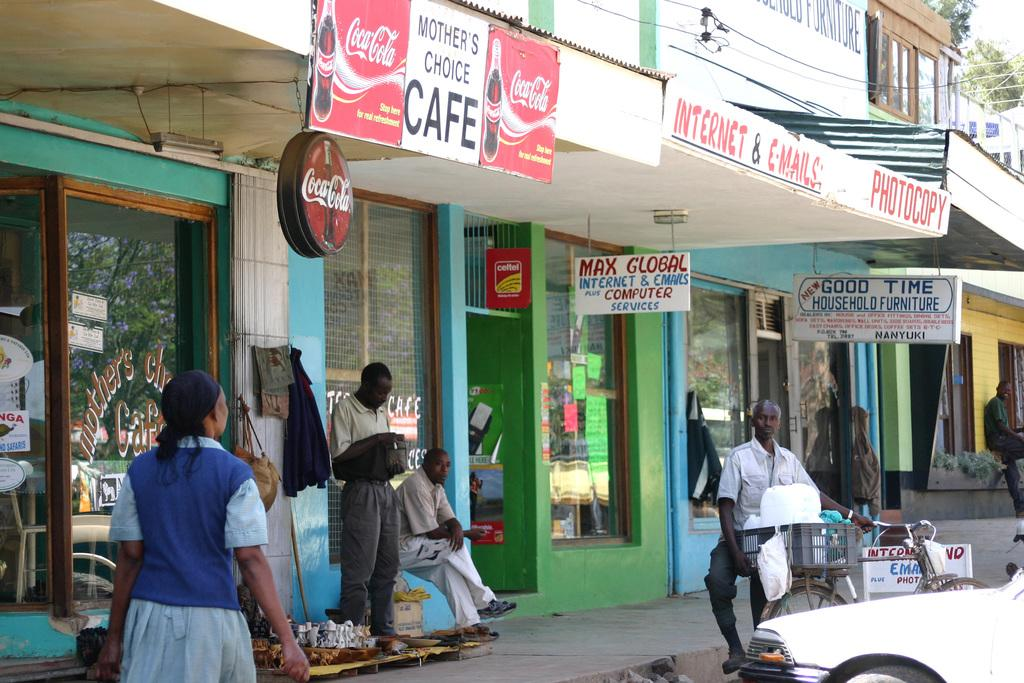<image>
Present a compact description of the photo's key features. A store where you can get internet access and check emails is on this street. 